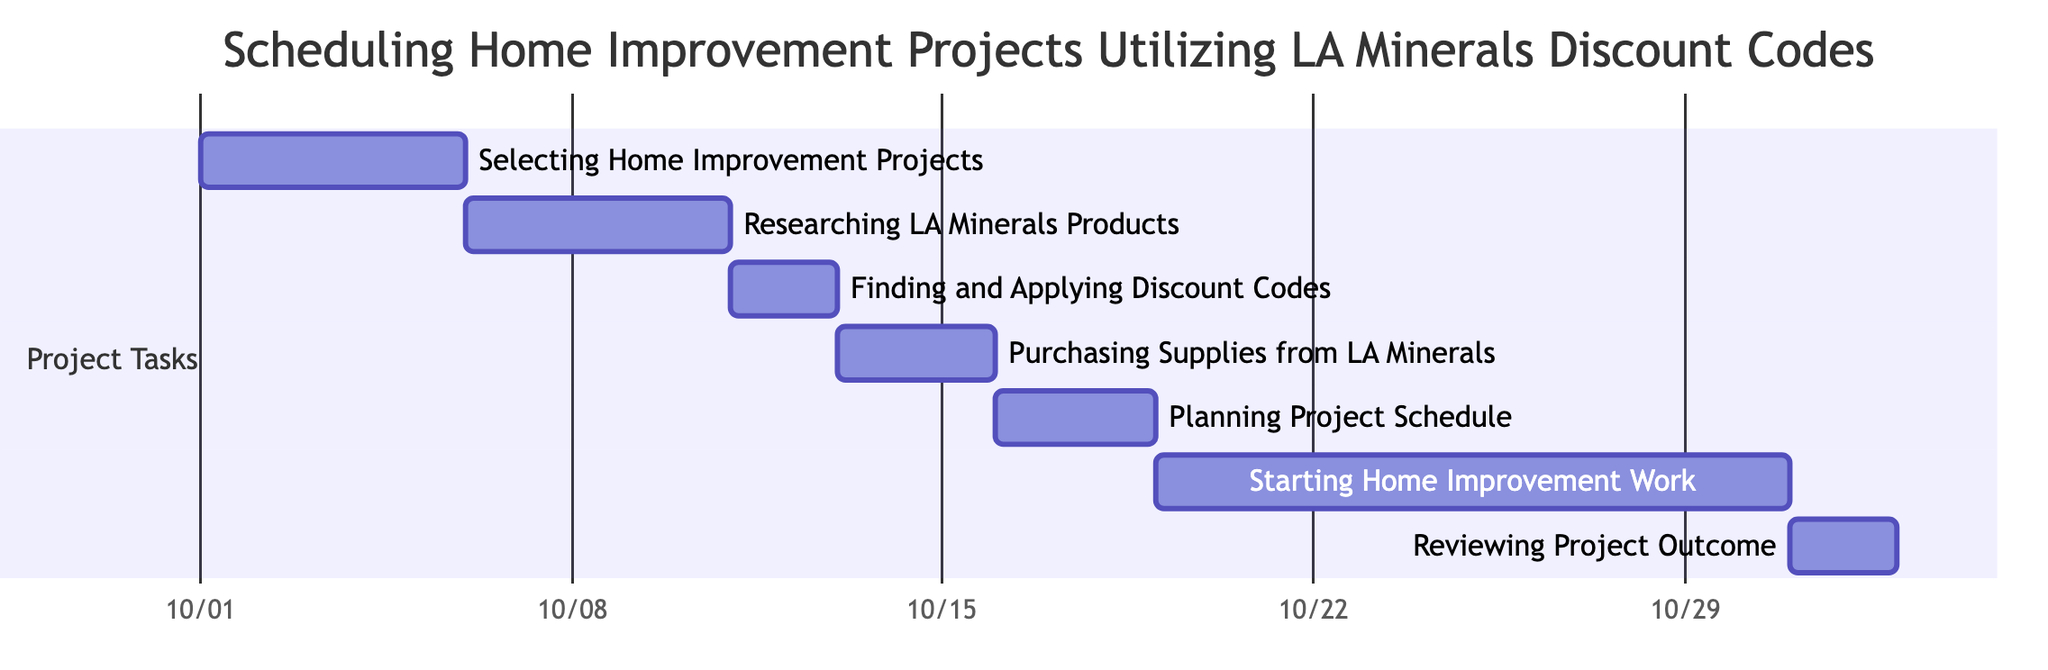What is the duration of "Researching LA Minerals Products"? The duration of the task "Researching LA Minerals Products" is listed as 5 days, which can be verified directly from the diagram where the task starts on October 6 and ends on October 10.
Answer: 5 days What task follows "Finding and Applying Discount Codes"? From the diagram, after the task "Finding and Applying Discount Codes" that ends on October 12, the subsequent task is "Purchasing Supplies from LA Minerals," which starts on October 13.
Answer: Purchasing Supplies from LA Minerals How many days does the "Starting Home Improvement Work" task last? The task "Starting Home Improvement Work" starts on October 19 and ends on October 30. By calculating the total duration, it lasts for 12 days.
Answer: 12 days What is the earliest start date of any task in the diagram? Reviewing the start dates of all tasks, the earliest start date is October 1, marked by the task "Selecting Home Improvement Projects."
Answer: October 1 Which task has the shortest duration? By examining all the tasks, the task "Finding and Applying Discount Codes" has the shortest duration of 2 days, as indicated in the diagram.
Answer: 2 days What is the total number of tasks represented in the Gantt chart? The diagram displays a total of 7 tasks, which can be counted directly from the tasks listed in the section titled "Project Tasks."
Answer: 7 What are the start and end dates for "Planning Project Schedule"? According to the diagram, the task "Planning Project Schedule" starts on October 16 and ends on October 18. This information is directly provided in the task's data.
Answer: October 16 to October 18 Which task is the last in the sequence? The final task in the sequence is "Reviewing Project Outcome," which is displayed last in the diagram and occurs after all other tasks have been completed.
Answer: Reviewing Project Outcome 